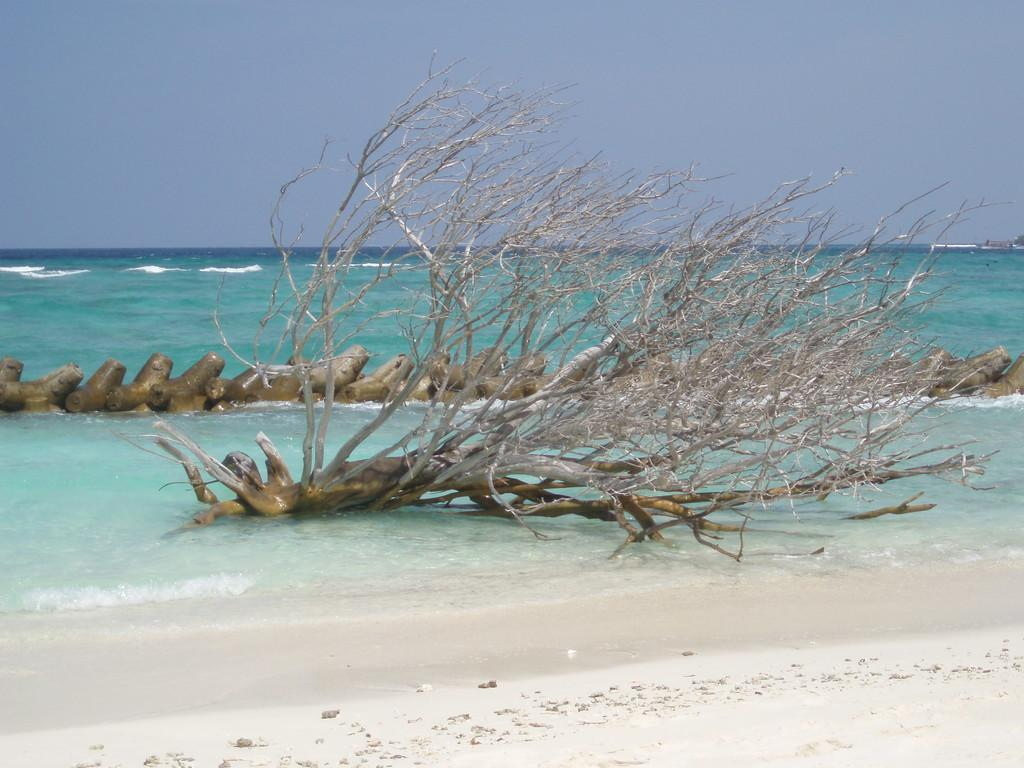What is located in the water in the image? There is a tree and a wooden log in the water. Can you describe the wooden log in the image? The wooden log stretches from left to right in the water. What can be observed about the water in the image? Waves are visible in the water. How many sheep are grazing on the hill in the image? There are no sheep or hills present in the image; it features a tree and a wooden log in the water. What color is the eye of the creature in the image? There is no creature or eye present in the image. 